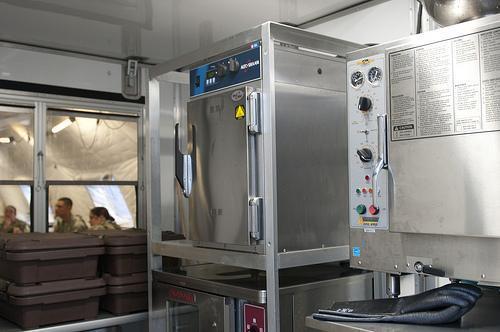How many windows are visible?
Give a very brief answer. 2. 